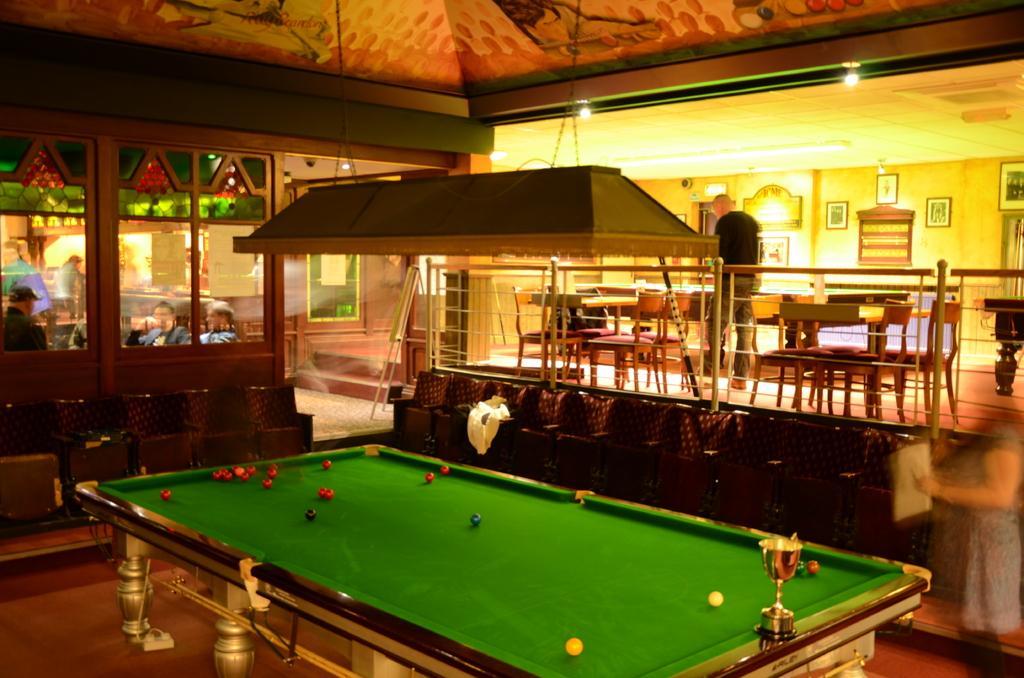Describe this image in one or two sentences. It is a pub , there is a snooker table with balls over it beside the table there is a big sofa behind it there are some tables and chairs and a person is standing in between them left side to that there is a room in which some people are sitting in the background there is a yellow color wall and some photo posters on it. 